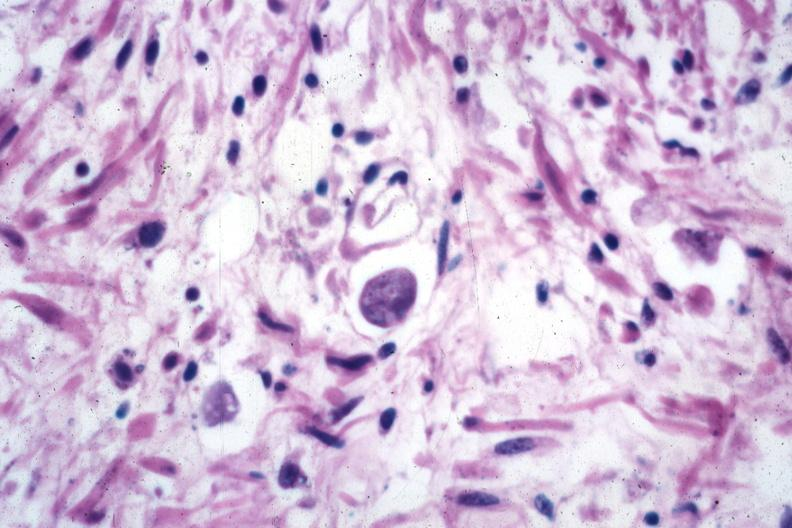what is present?
Answer the question using a single word or phrase. Colon 